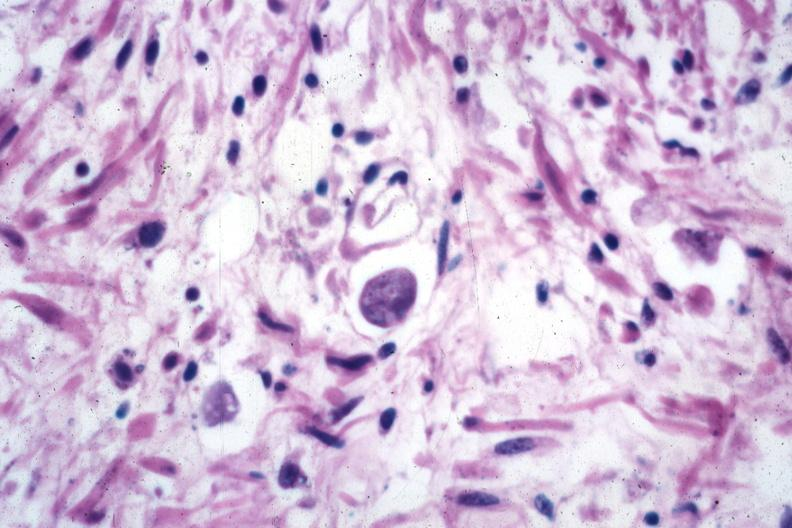what is present?
Answer the question using a single word or phrase. Colon 